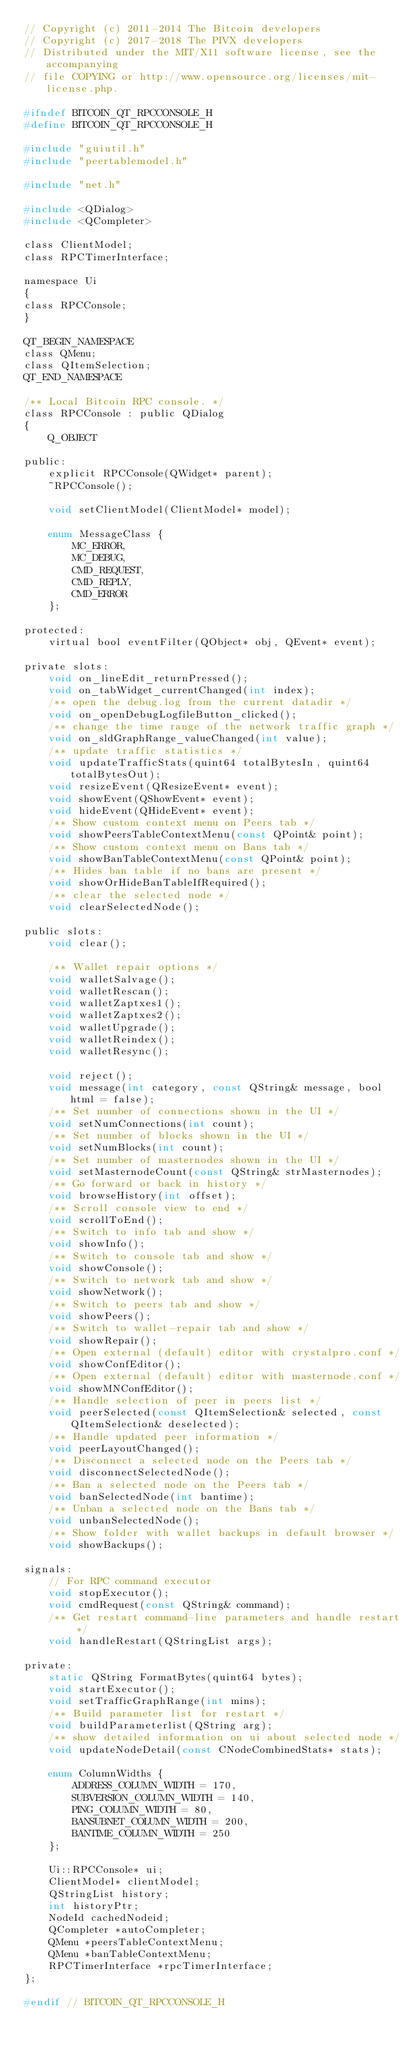Convert code to text. <code><loc_0><loc_0><loc_500><loc_500><_C_>// Copyright (c) 2011-2014 The Bitcoin developers
// Copyright (c) 2017-2018 The PIVX developers
// Distributed under the MIT/X11 software license, see the accompanying
// file COPYING or http://www.opensource.org/licenses/mit-license.php.

#ifndef BITCOIN_QT_RPCCONSOLE_H
#define BITCOIN_QT_RPCCONSOLE_H

#include "guiutil.h"
#include "peertablemodel.h"

#include "net.h"

#include <QDialog>
#include <QCompleter>

class ClientModel;
class RPCTimerInterface;

namespace Ui
{
class RPCConsole;
}

QT_BEGIN_NAMESPACE
class QMenu;
class QItemSelection;
QT_END_NAMESPACE

/** Local Bitcoin RPC console. */
class RPCConsole : public QDialog
{
    Q_OBJECT

public:
    explicit RPCConsole(QWidget* parent);
    ~RPCConsole();

    void setClientModel(ClientModel* model);

    enum MessageClass {
        MC_ERROR,
        MC_DEBUG,
        CMD_REQUEST,
        CMD_REPLY,
        CMD_ERROR
    };

protected:
    virtual bool eventFilter(QObject* obj, QEvent* event);

private slots:
    void on_lineEdit_returnPressed();
    void on_tabWidget_currentChanged(int index);
    /** open the debug.log from the current datadir */
    void on_openDebugLogfileButton_clicked();
    /** change the time range of the network traffic graph */
    void on_sldGraphRange_valueChanged(int value);
    /** update traffic statistics */
    void updateTrafficStats(quint64 totalBytesIn, quint64 totalBytesOut);
    void resizeEvent(QResizeEvent* event);
    void showEvent(QShowEvent* event);
    void hideEvent(QHideEvent* event);
    /** Show custom context menu on Peers tab */
    void showPeersTableContextMenu(const QPoint& point);
    /** Show custom context menu on Bans tab */
    void showBanTableContextMenu(const QPoint& point);
    /** Hides ban table if no bans are present */
    void showOrHideBanTableIfRequired();
    /** clear the selected node */
    void clearSelectedNode();

public slots:
    void clear();

    /** Wallet repair options */
    void walletSalvage();
    void walletRescan();
    void walletZaptxes1();
    void walletZaptxes2();
    void walletUpgrade();
    void walletReindex();
    void walletResync();

    void reject();
    void message(int category, const QString& message, bool html = false);
    /** Set number of connections shown in the UI */
    void setNumConnections(int count);
    /** Set number of blocks shown in the UI */
    void setNumBlocks(int count);
    /** Set number of masternodes shown in the UI */
    void setMasternodeCount(const QString& strMasternodes);
    /** Go forward or back in history */
    void browseHistory(int offset);
    /** Scroll console view to end */
    void scrollToEnd();
    /** Switch to info tab and show */
    void showInfo();
    /** Switch to console tab and show */
    void showConsole();
    /** Switch to network tab and show */
    void showNetwork();
    /** Switch to peers tab and show */
    void showPeers();
    /** Switch to wallet-repair tab and show */
    void showRepair();
    /** Open external (default) editor with crystalpro.conf */
    void showConfEditor();
    /** Open external (default) editor with masternode.conf */
    void showMNConfEditor();
    /** Handle selection of peer in peers list */
    void peerSelected(const QItemSelection& selected, const QItemSelection& deselected);
    /** Handle updated peer information */
    void peerLayoutChanged();
    /** Disconnect a selected node on the Peers tab */
    void disconnectSelectedNode();
    /** Ban a selected node on the Peers tab */
    void banSelectedNode(int bantime);
    /** Unban a selected node on the Bans tab */
    void unbanSelectedNode();
    /** Show folder with wallet backups in default browser */
    void showBackups();

signals:
    // For RPC command executor
    void stopExecutor();
    void cmdRequest(const QString& command);
    /** Get restart command-line parameters and handle restart */
    void handleRestart(QStringList args);

private:
    static QString FormatBytes(quint64 bytes);
    void startExecutor();
    void setTrafficGraphRange(int mins);
    /** Build parameter list for restart */
    void buildParameterlist(QString arg);
    /** show detailed information on ui about selected node */
    void updateNodeDetail(const CNodeCombinedStats* stats);

    enum ColumnWidths {
        ADDRESS_COLUMN_WIDTH = 170,
        SUBVERSION_COLUMN_WIDTH = 140,
        PING_COLUMN_WIDTH = 80,
        BANSUBNET_COLUMN_WIDTH = 200,
        BANTIME_COLUMN_WIDTH = 250
    };

    Ui::RPCConsole* ui;
    ClientModel* clientModel;
    QStringList history;
    int historyPtr;
    NodeId cachedNodeid;
    QCompleter *autoCompleter;
    QMenu *peersTableContextMenu;
    QMenu *banTableContextMenu;
    RPCTimerInterface *rpcTimerInterface;
};

#endif // BITCOIN_QT_RPCCONSOLE_H
</code> 